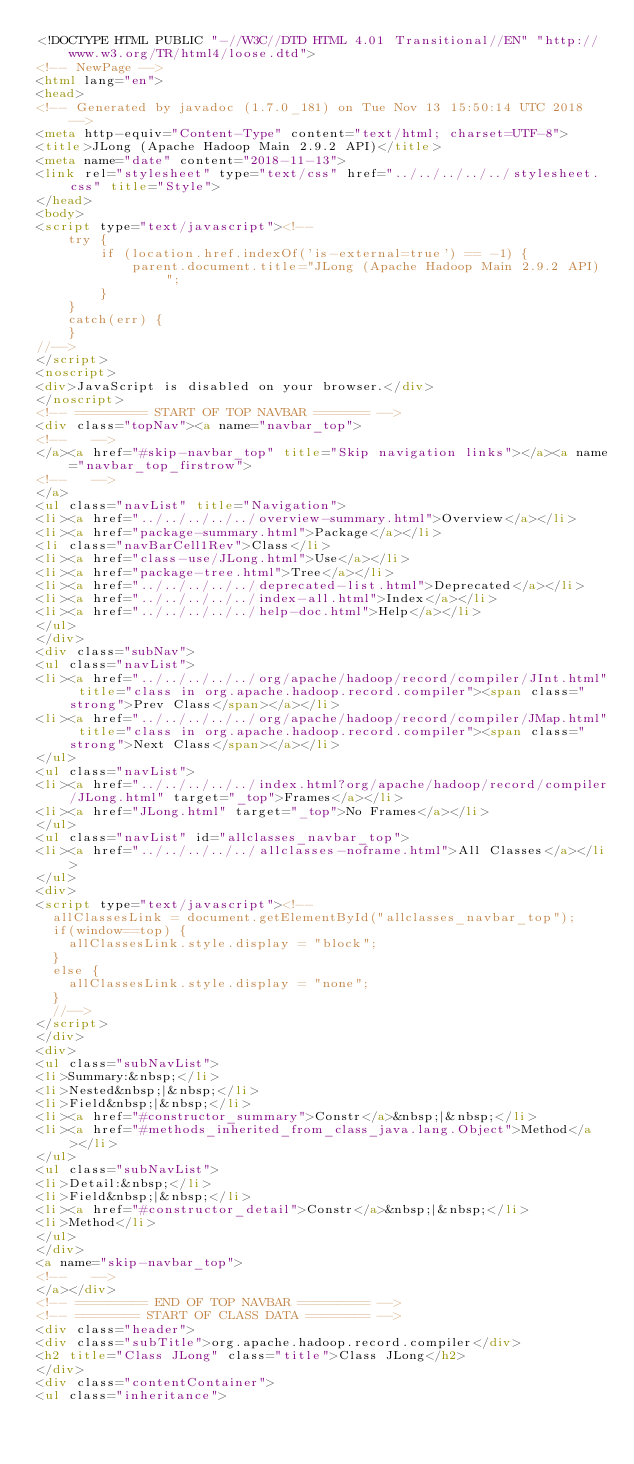Convert code to text. <code><loc_0><loc_0><loc_500><loc_500><_HTML_><!DOCTYPE HTML PUBLIC "-//W3C//DTD HTML 4.01 Transitional//EN" "http://www.w3.org/TR/html4/loose.dtd">
<!-- NewPage -->
<html lang="en">
<head>
<!-- Generated by javadoc (1.7.0_181) on Tue Nov 13 15:50:14 UTC 2018 -->
<meta http-equiv="Content-Type" content="text/html; charset=UTF-8">
<title>JLong (Apache Hadoop Main 2.9.2 API)</title>
<meta name="date" content="2018-11-13">
<link rel="stylesheet" type="text/css" href="../../../../../stylesheet.css" title="Style">
</head>
<body>
<script type="text/javascript"><!--
    try {
        if (location.href.indexOf('is-external=true') == -1) {
            parent.document.title="JLong (Apache Hadoop Main 2.9.2 API)";
        }
    }
    catch(err) {
    }
//-->
</script>
<noscript>
<div>JavaScript is disabled on your browser.</div>
</noscript>
<!-- ========= START OF TOP NAVBAR ======= -->
<div class="topNav"><a name="navbar_top">
<!--   -->
</a><a href="#skip-navbar_top" title="Skip navigation links"></a><a name="navbar_top_firstrow">
<!--   -->
</a>
<ul class="navList" title="Navigation">
<li><a href="../../../../../overview-summary.html">Overview</a></li>
<li><a href="package-summary.html">Package</a></li>
<li class="navBarCell1Rev">Class</li>
<li><a href="class-use/JLong.html">Use</a></li>
<li><a href="package-tree.html">Tree</a></li>
<li><a href="../../../../../deprecated-list.html">Deprecated</a></li>
<li><a href="../../../../../index-all.html">Index</a></li>
<li><a href="../../../../../help-doc.html">Help</a></li>
</ul>
</div>
<div class="subNav">
<ul class="navList">
<li><a href="../../../../../org/apache/hadoop/record/compiler/JInt.html" title="class in org.apache.hadoop.record.compiler"><span class="strong">Prev Class</span></a></li>
<li><a href="../../../../../org/apache/hadoop/record/compiler/JMap.html" title="class in org.apache.hadoop.record.compiler"><span class="strong">Next Class</span></a></li>
</ul>
<ul class="navList">
<li><a href="../../../../../index.html?org/apache/hadoop/record/compiler/JLong.html" target="_top">Frames</a></li>
<li><a href="JLong.html" target="_top">No Frames</a></li>
</ul>
<ul class="navList" id="allclasses_navbar_top">
<li><a href="../../../../../allclasses-noframe.html">All Classes</a></li>
</ul>
<div>
<script type="text/javascript"><!--
  allClassesLink = document.getElementById("allclasses_navbar_top");
  if(window==top) {
    allClassesLink.style.display = "block";
  }
  else {
    allClassesLink.style.display = "none";
  }
  //-->
</script>
</div>
<div>
<ul class="subNavList">
<li>Summary:&nbsp;</li>
<li>Nested&nbsp;|&nbsp;</li>
<li>Field&nbsp;|&nbsp;</li>
<li><a href="#constructor_summary">Constr</a>&nbsp;|&nbsp;</li>
<li><a href="#methods_inherited_from_class_java.lang.Object">Method</a></li>
</ul>
<ul class="subNavList">
<li>Detail:&nbsp;</li>
<li>Field&nbsp;|&nbsp;</li>
<li><a href="#constructor_detail">Constr</a>&nbsp;|&nbsp;</li>
<li>Method</li>
</ul>
</div>
<a name="skip-navbar_top">
<!--   -->
</a></div>
<!-- ========= END OF TOP NAVBAR ========= -->
<!-- ======== START OF CLASS DATA ======== -->
<div class="header">
<div class="subTitle">org.apache.hadoop.record.compiler</div>
<h2 title="Class JLong" class="title">Class JLong</h2>
</div>
<div class="contentContainer">
<ul class="inheritance"></code> 